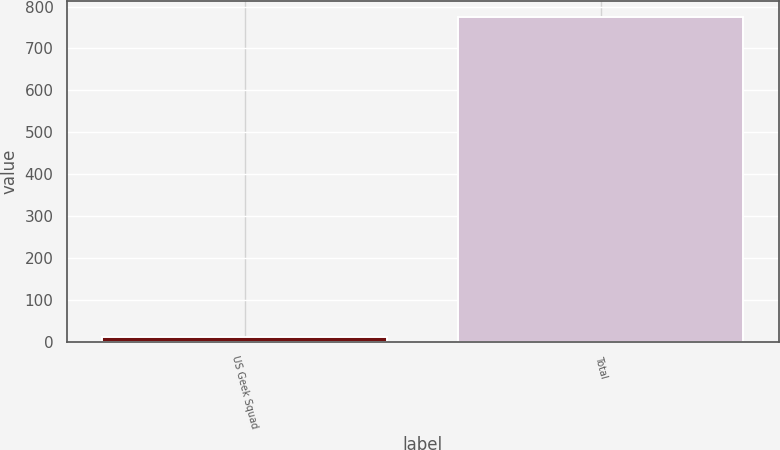Convert chart to OTSL. <chart><loc_0><loc_0><loc_500><loc_500><bar_chart><fcel>US Geek Squad<fcel>Total<nl><fcel>12<fcel>774<nl></chart> 